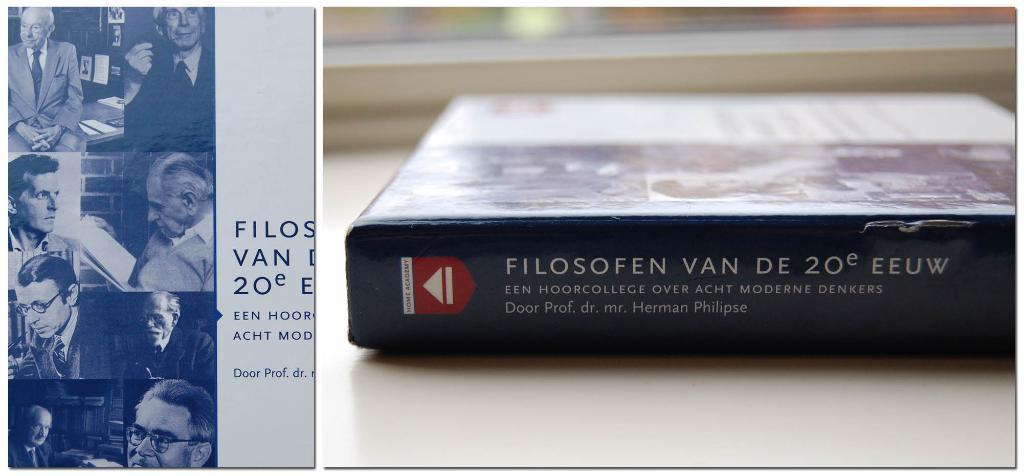<image>
Provide a brief description of the given image. A book which is by Herman Philipse and has a black spine. 